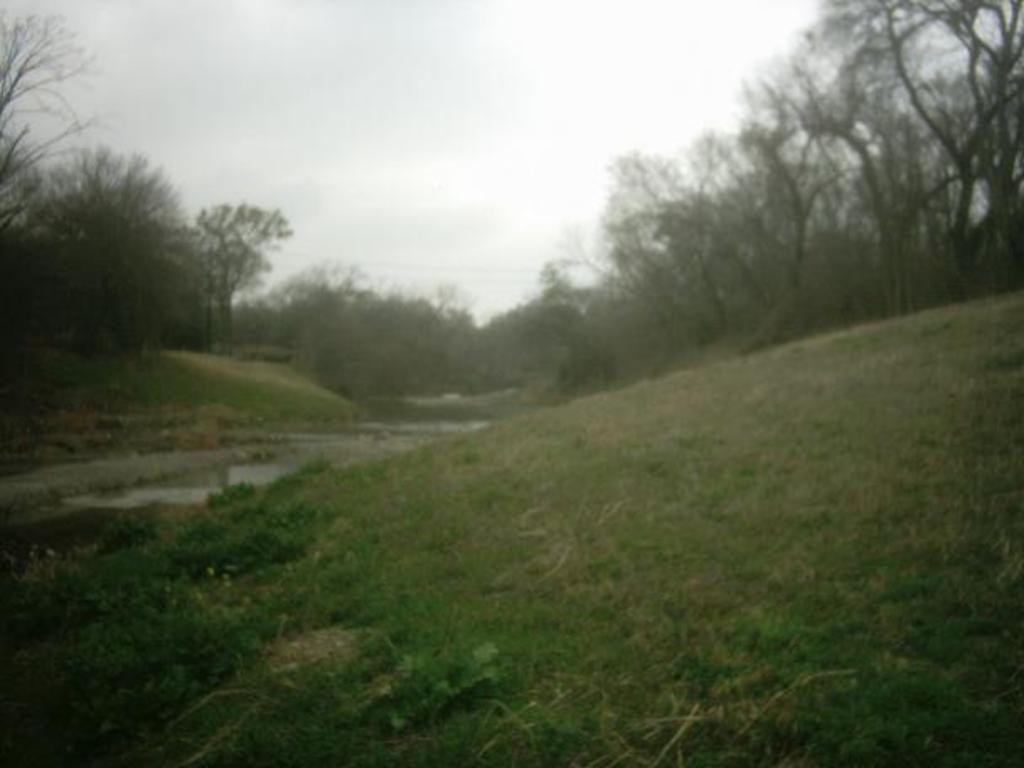Please provide a concise description of this image. In this image at the bottom there is grass and on the left side there is one pond. In the background there are some trees, plants and grass and at the top there is sky. 